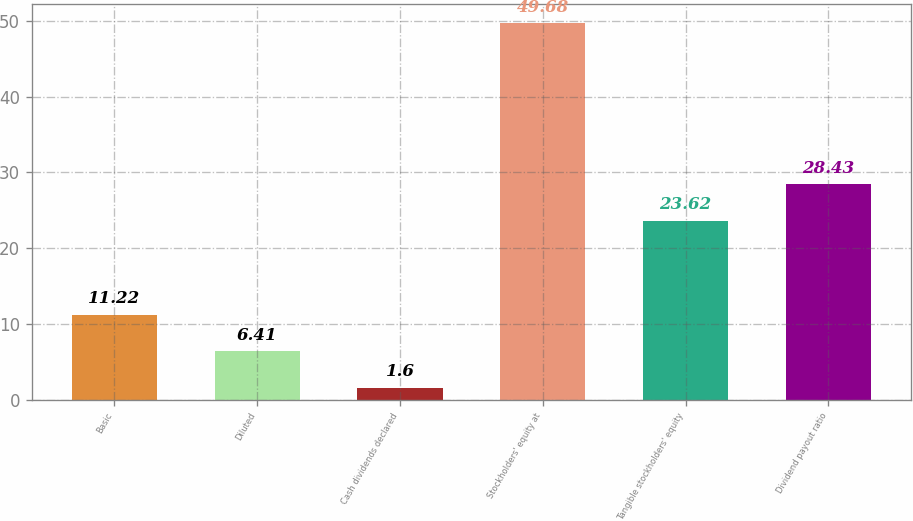<chart> <loc_0><loc_0><loc_500><loc_500><bar_chart><fcel>Basic<fcel>Diluted<fcel>Cash dividends declared<fcel>Stockholders' equity at<fcel>Tangible stockholders' equity<fcel>Dividend payout ratio<nl><fcel>11.22<fcel>6.41<fcel>1.6<fcel>49.68<fcel>23.62<fcel>28.43<nl></chart> 